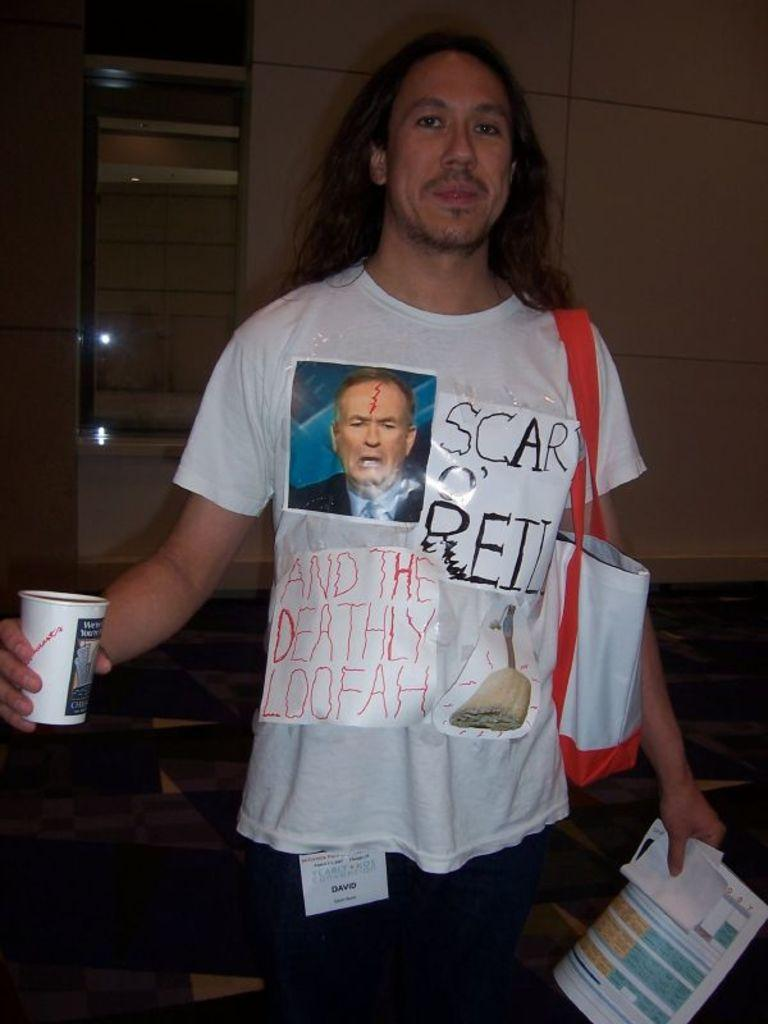<image>
Give a short and clear explanation of the subsequent image. A man is wearing a shirt mocking Bill O'Reilly. 